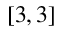<formula> <loc_0><loc_0><loc_500><loc_500>[ 3 , 3 ]</formula> 